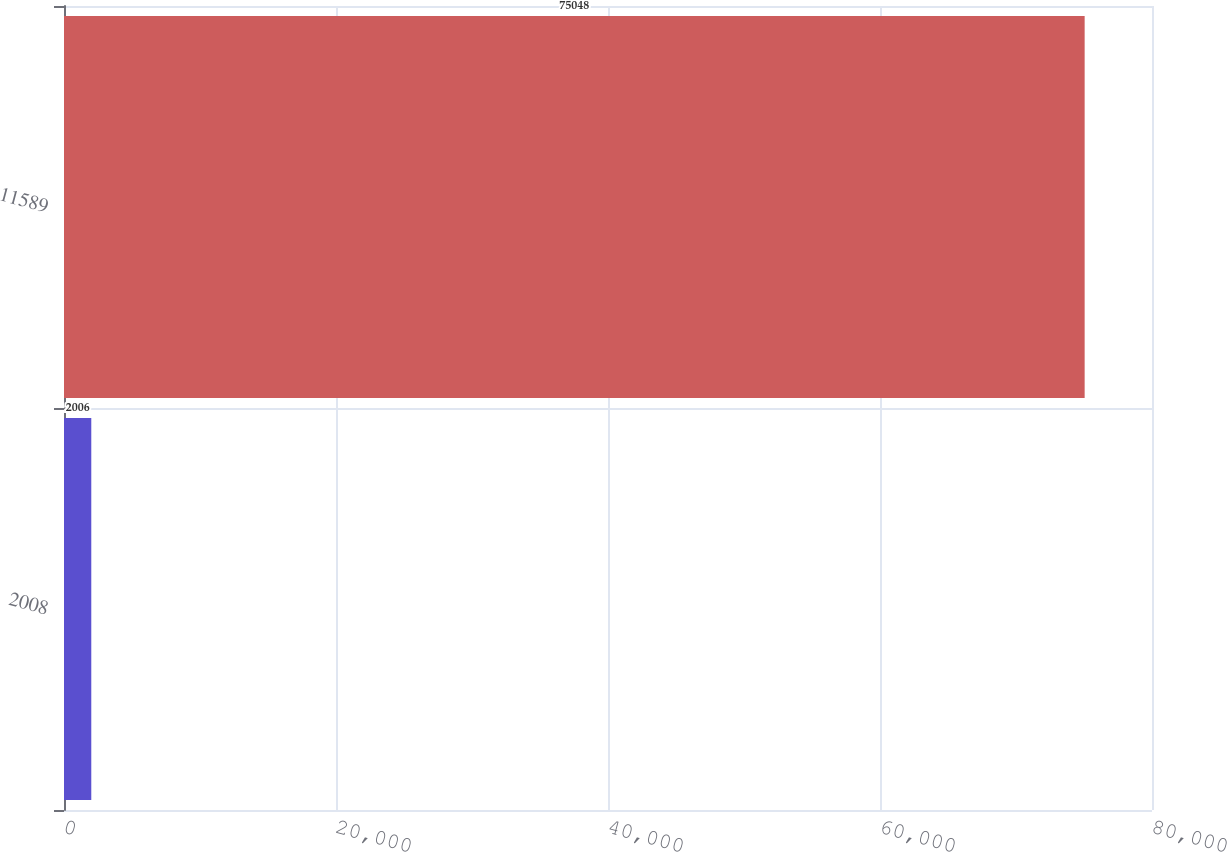Convert chart to OTSL. <chart><loc_0><loc_0><loc_500><loc_500><bar_chart><fcel>2008<fcel>11589<nl><fcel>2006<fcel>75048<nl></chart> 